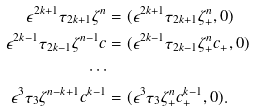<formula> <loc_0><loc_0><loc_500><loc_500>\epsilon ^ { 2 k + 1 } \tau _ { 2 k + 1 } \zeta ^ { n } & = ( \epsilon ^ { 2 k + 1 } \tau _ { 2 k + 1 } \zeta _ { + } ^ { n } , 0 ) \\ \epsilon ^ { 2 k - 1 } \tau _ { 2 k - 1 } \zeta ^ { n - 1 } c & = ( \epsilon ^ { 2 k - 1 } \tau _ { 2 k - 1 } \zeta _ { + } ^ { n } c _ { + } , 0 ) \\ \cdots \\ \epsilon ^ { 3 } \tau _ { 3 } \zeta ^ { n - k + 1 } c ^ { k - 1 } & = ( \epsilon ^ { 3 } \tau _ { 3 } \zeta _ { + } ^ { n } c _ { + } ^ { k - 1 } , 0 ) .</formula> 